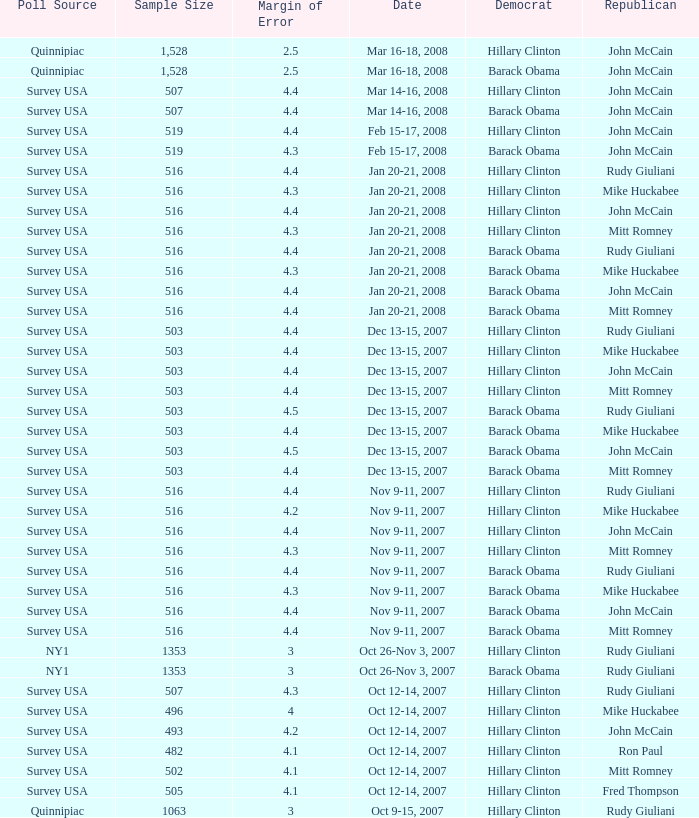In a poll with a sample size under 516, which democrat was selected when ron paul was the chosen republican? Hillary Clinton. 